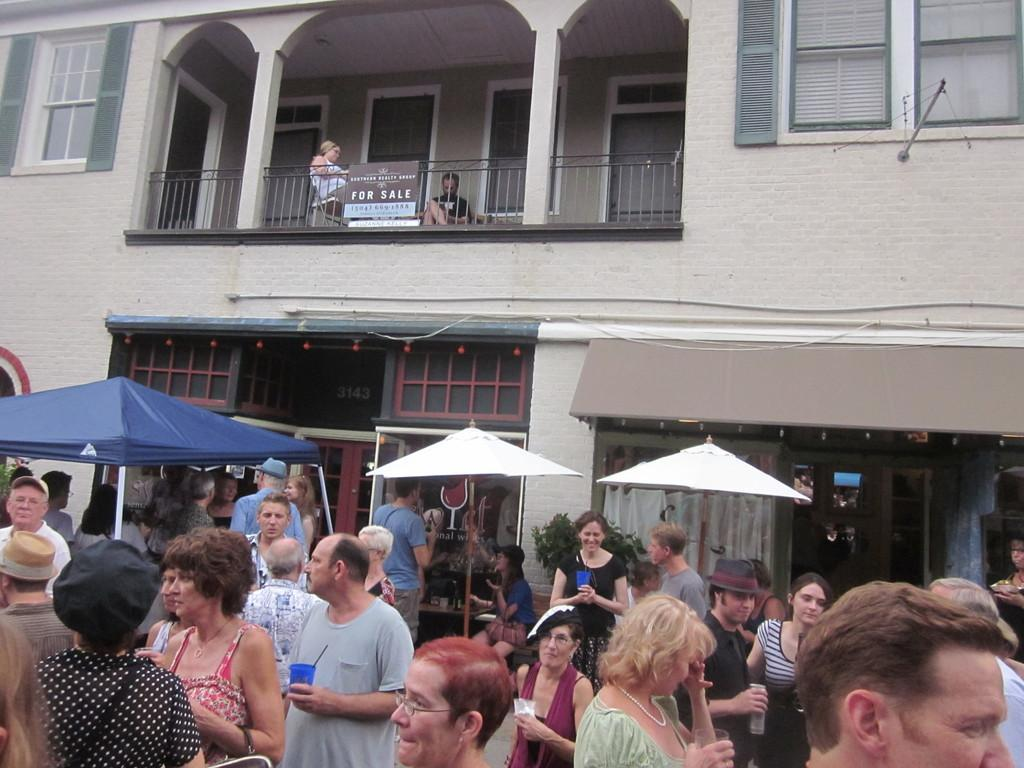Provide a one-sentence caption for the provided image. Block party located outside a home that is for sale. 